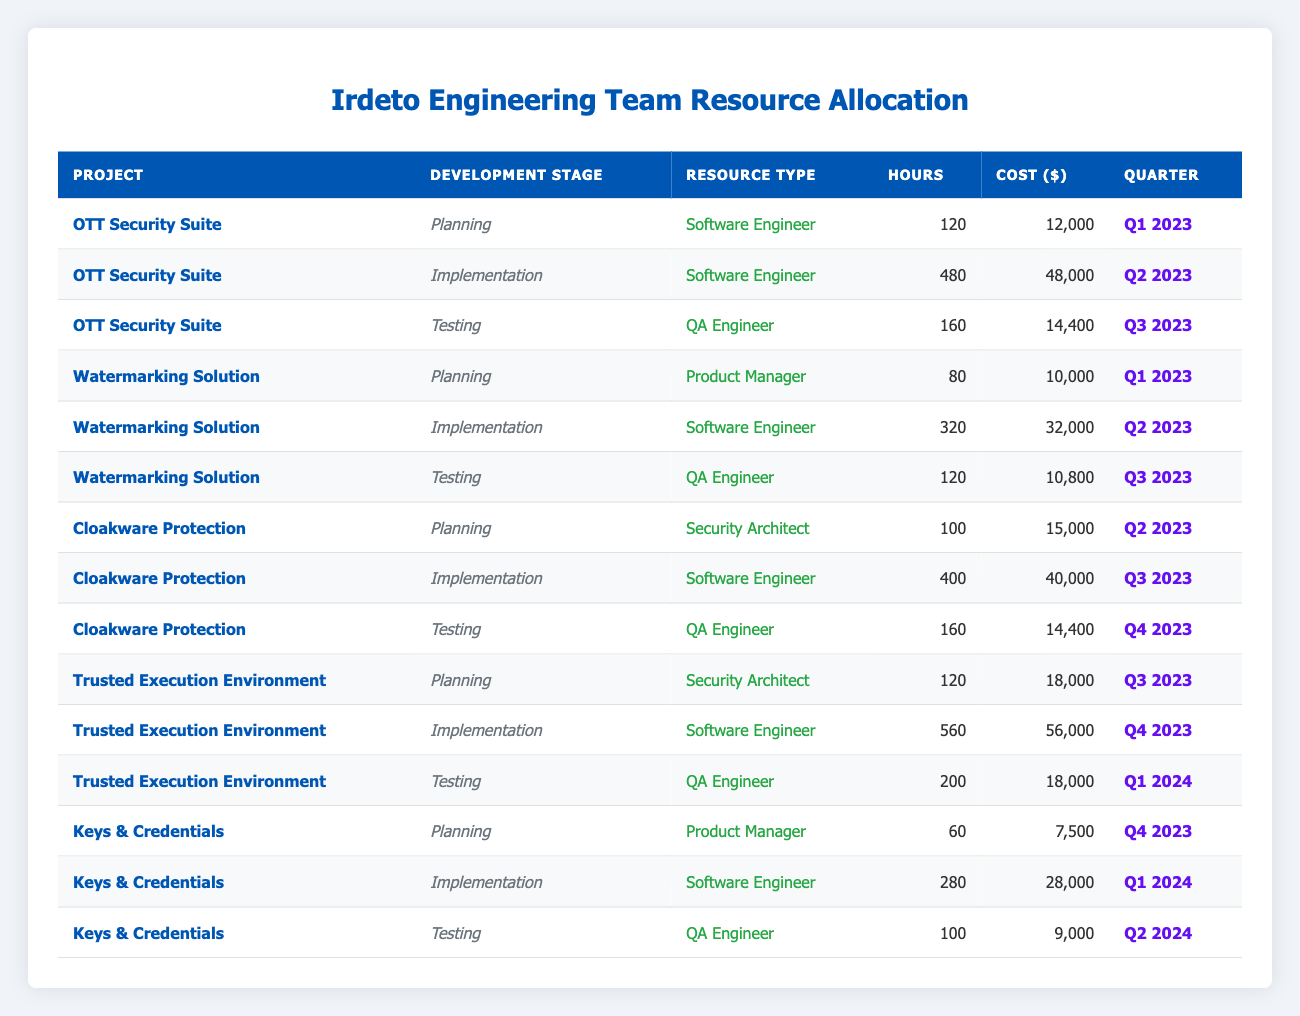What is the total cost allocated for the "Watermarking Solution" project? Adding the costs for each development stage of the project: Planning (10,000) + Implementation (32,000) + Testing (10,800) = 52,800.
Answer: 52,800 How many hours have been allocated in total for the "Cloakware Protection" project? Summing the hours for each stage: Planning (100) + Implementation (400) + Testing (160) = 660 hours in total.
Answer: 660 Which resource type spent the most hours in the "Trusted Execution Environment" project? Looking at the hours: Planning (120 hours by Security Architect), Implementation (560 hours by Software Engineer), Testing (200 hours by QA Engineer). The maximum is 560 hours by Software Engineer.
Answer: Software Engineer Was there any allocation for "Keys & Credentials" project in Q3 2023? Checking the table for "Keys & Credentials" project and finding no entries for Q3 2023. Therefore, the answer is no.
Answer: No What is the average cost per hour for resource allocation across all projects? Total cost is 285,300. The total hours allocated are: 120 + 480 + 160 + 80 + 320 + 120 + 100 + 400 + 160 + 120 + 560 + 200 + 60 + 280 + 100 = 2,580 hours. Average cost is 285,300 / 2,580 = 110.61 (rounded).
Answer: 110.61 What is the total number of hours allocated to QA Engineers across all projects? From the table: OTT Security Suite (160) + Watermarking Solution (120) + Cloakware Protection (160) + Trusted Execution Environment (200) + Keys & Credentials (100) = 840 hours total for QA Engineers.
Answer: 840 Is there a project that has used "Security Architect" as the resource type in the "Implementation" stage? Reviewing the table, there are no instances of "Security Architect" in the Implementation stage, which confirms this as false.
Answer: No How much more is spent on the "Implementation" stage than the "Planning" stage across all projects? Total costs for Implementation: 48,000 (OTT) + 32,000 (Watermarking) + 40,000 (Cloakware) + 56,000 (Trusted Execution) + 28,000 (Keys) = 204,000. Total for Planning: 12,000 + 10,000 + 15,000 + 18,000 + 7,500 = 62,500. The difference is 204,000 - 62,500 = 141,500.
Answer: 141,500 